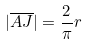Convert formula to latex. <formula><loc_0><loc_0><loc_500><loc_500>| \overline { A J } | = \frac { 2 } { \pi } r</formula> 